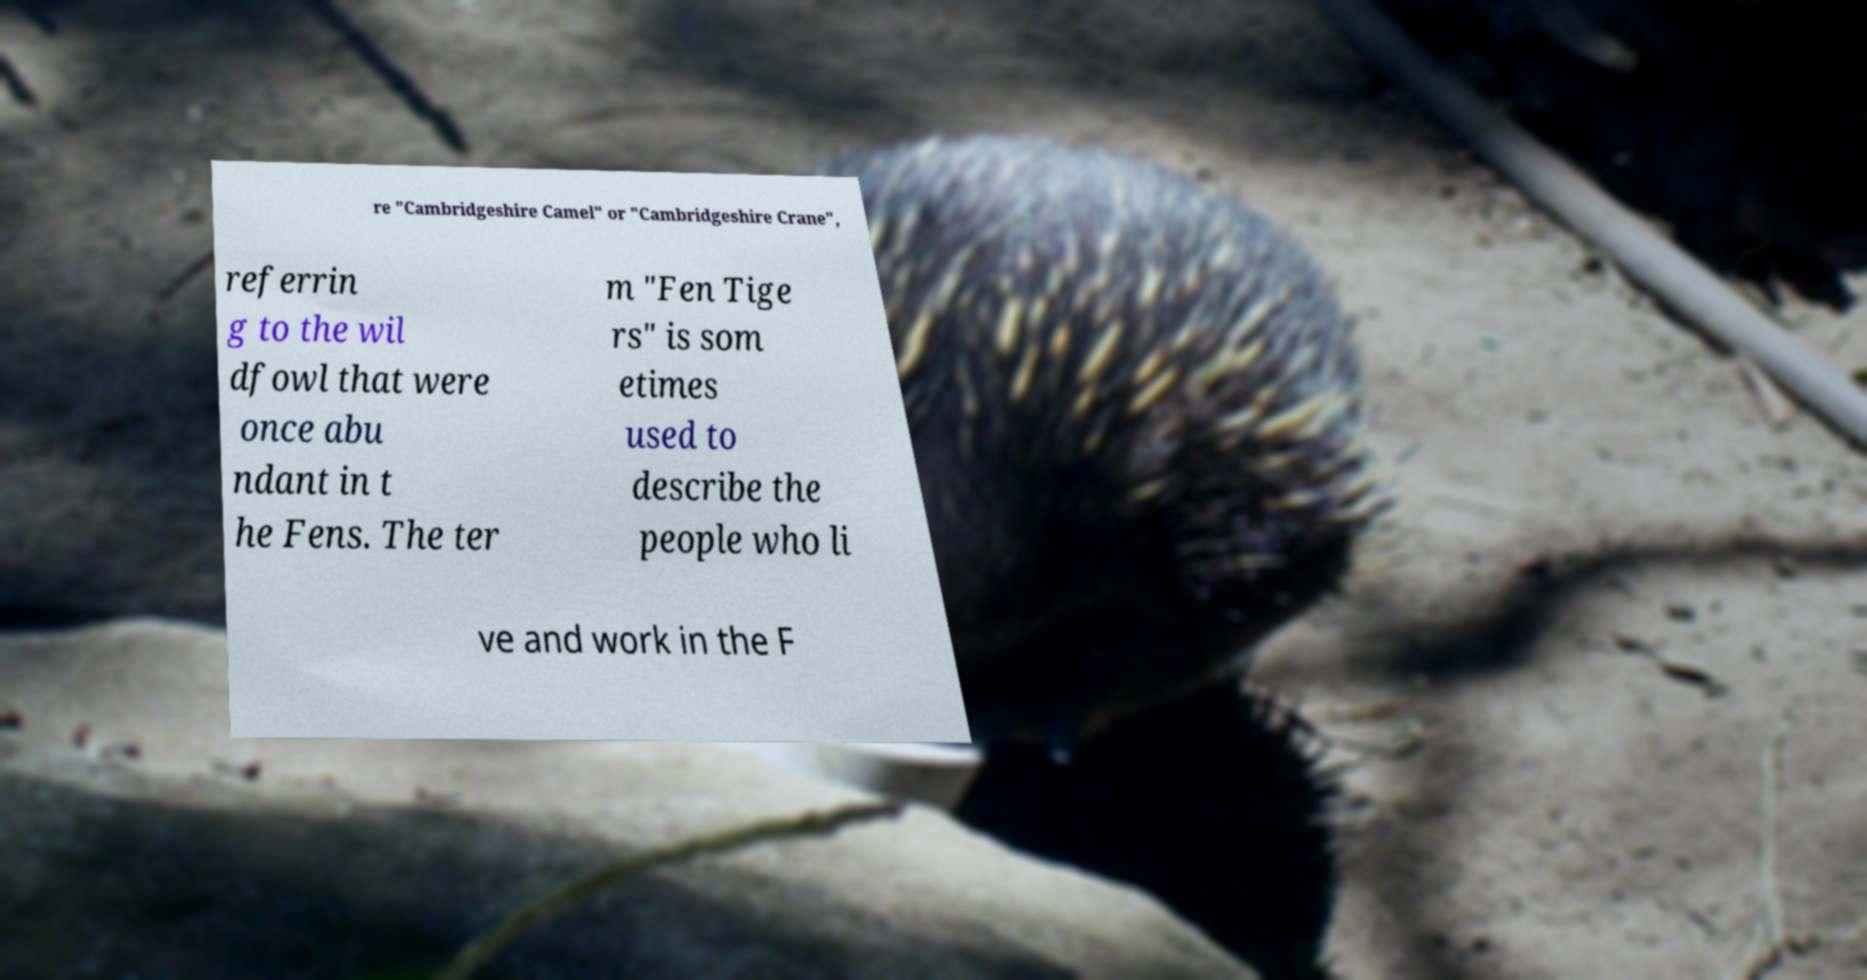Please identify and transcribe the text found in this image. re "Cambridgeshire Camel" or "Cambridgeshire Crane", referrin g to the wil dfowl that were once abu ndant in t he Fens. The ter m "Fen Tige rs" is som etimes used to describe the people who li ve and work in the F 